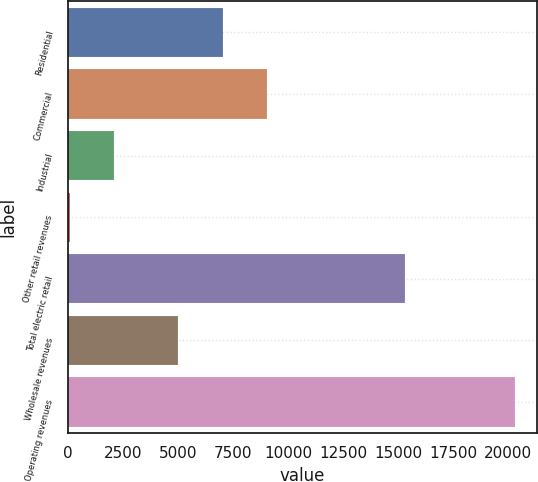<chart> <loc_0><loc_0><loc_500><loc_500><bar_chart><fcel>Residential<fcel>Commercial<fcel>Industrial<fcel>Other retail revenues<fcel>Total electric retail<fcel>Wholesale revenues<fcel>Operating revenues<nl><fcel>7040.9<fcel>9064.8<fcel>2099.9<fcel>76<fcel>15298<fcel>5017<fcel>20315<nl></chart> 